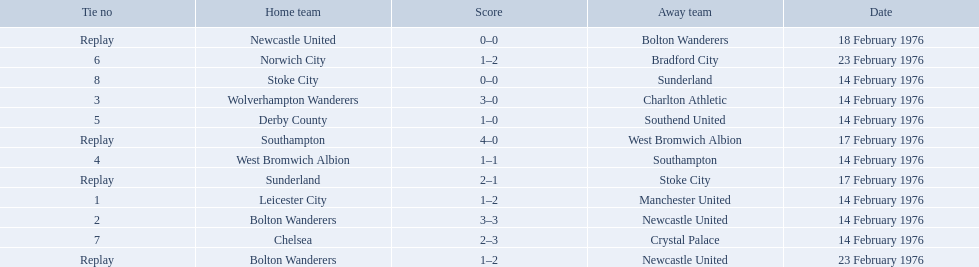Who were all the teams that played? Leicester City, Manchester United, Bolton Wanderers, Newcastle United, Newcastle United, Bolton Wanderers, Bolton Wanderers, Newcastle United, Wolverhampton Wanderers, Charlton Athletic, West Bromwich Albion, Southampton, Southampton, West Bromwich Albion, Derby County, Southend United, Norwich City, Bradford City, Chelsea, Crystal Palace, Stoke City, Sunderland, Sunderland, Stoke City. Which of these teams won? Manchester United, Newcastle United, Wolverhampton Wanderers, Southampton, Derby County, Bradford City, Crystal Palace, Sunderland. Could you parse the entire table as a dict? {'header': ['Tie no', 'Home team', 'Score', 'Away team', 'Date'], 'rows': [['Replay', 'Newcastle United', '0–0', 'Bolton Wanderers', '18 February 1976'], ['6', 'Norwich City', '1–2', 'Bradford City', '23 February 1976'], ['8', 'Stoke City', '0–0', 'Sunderland', '14 February 1976'], ['3', 'Wolverhampton Wanderers', '3–0', 'Charlton Athletic', '14 February 1976'], ['5', 'Derby County', '1–0', 'Southend United', '14 February 1976'], ['Replay', 'Southampton', '4–0', 'West Bromwich Albion', '17 February 1976'], ['4', 'West Bromwich Albion', '1–1', 'Southampton', '14 February 1976'], ['Replay', 'Sunderland', '2–1', 'Stoke City', '17 February 1976'], ['1', 'Leicester City', '1–2', 'Manchester United', '14 February 1976'], ['2', 'Bolton Wanderers', '3–3', 'Newcastle United', '14 February 1976'], ['7', 'Chelsea', '2–3', 'Crystal Palace', '14 February 1976'], ['Replay', 'Bolton Wanderers', '1–2', 'Newcastle United', '23 February 1976']]} What was manchester united's winning score? 1–2. What was the wolverhampton wonders winning score? 3–0. Which of these two teams had the better winning score? Wolverhampton Wanderers. What is the game at the top of the table? 1. Who is the home team for this game? Leicester City. 